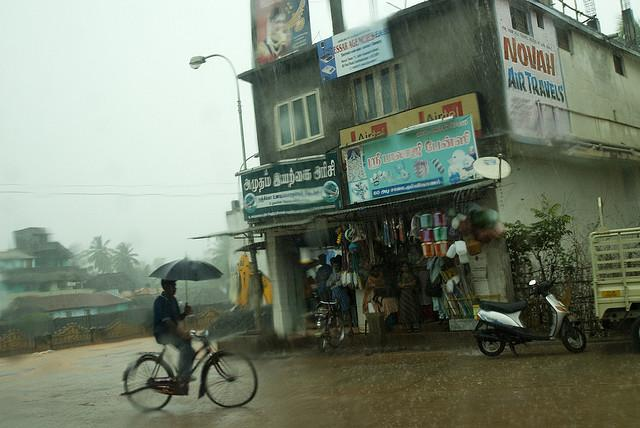Which person gets the most soaked? Please explain your reasoning. cyclist. The cyclist is in the rain and while holding an umbrella, will likely be hit outside the range of the umbrella and from spray off of the bike, other passing vehicles etc. they are the only person visible outside of shelter from the rain and actively getting wet. 